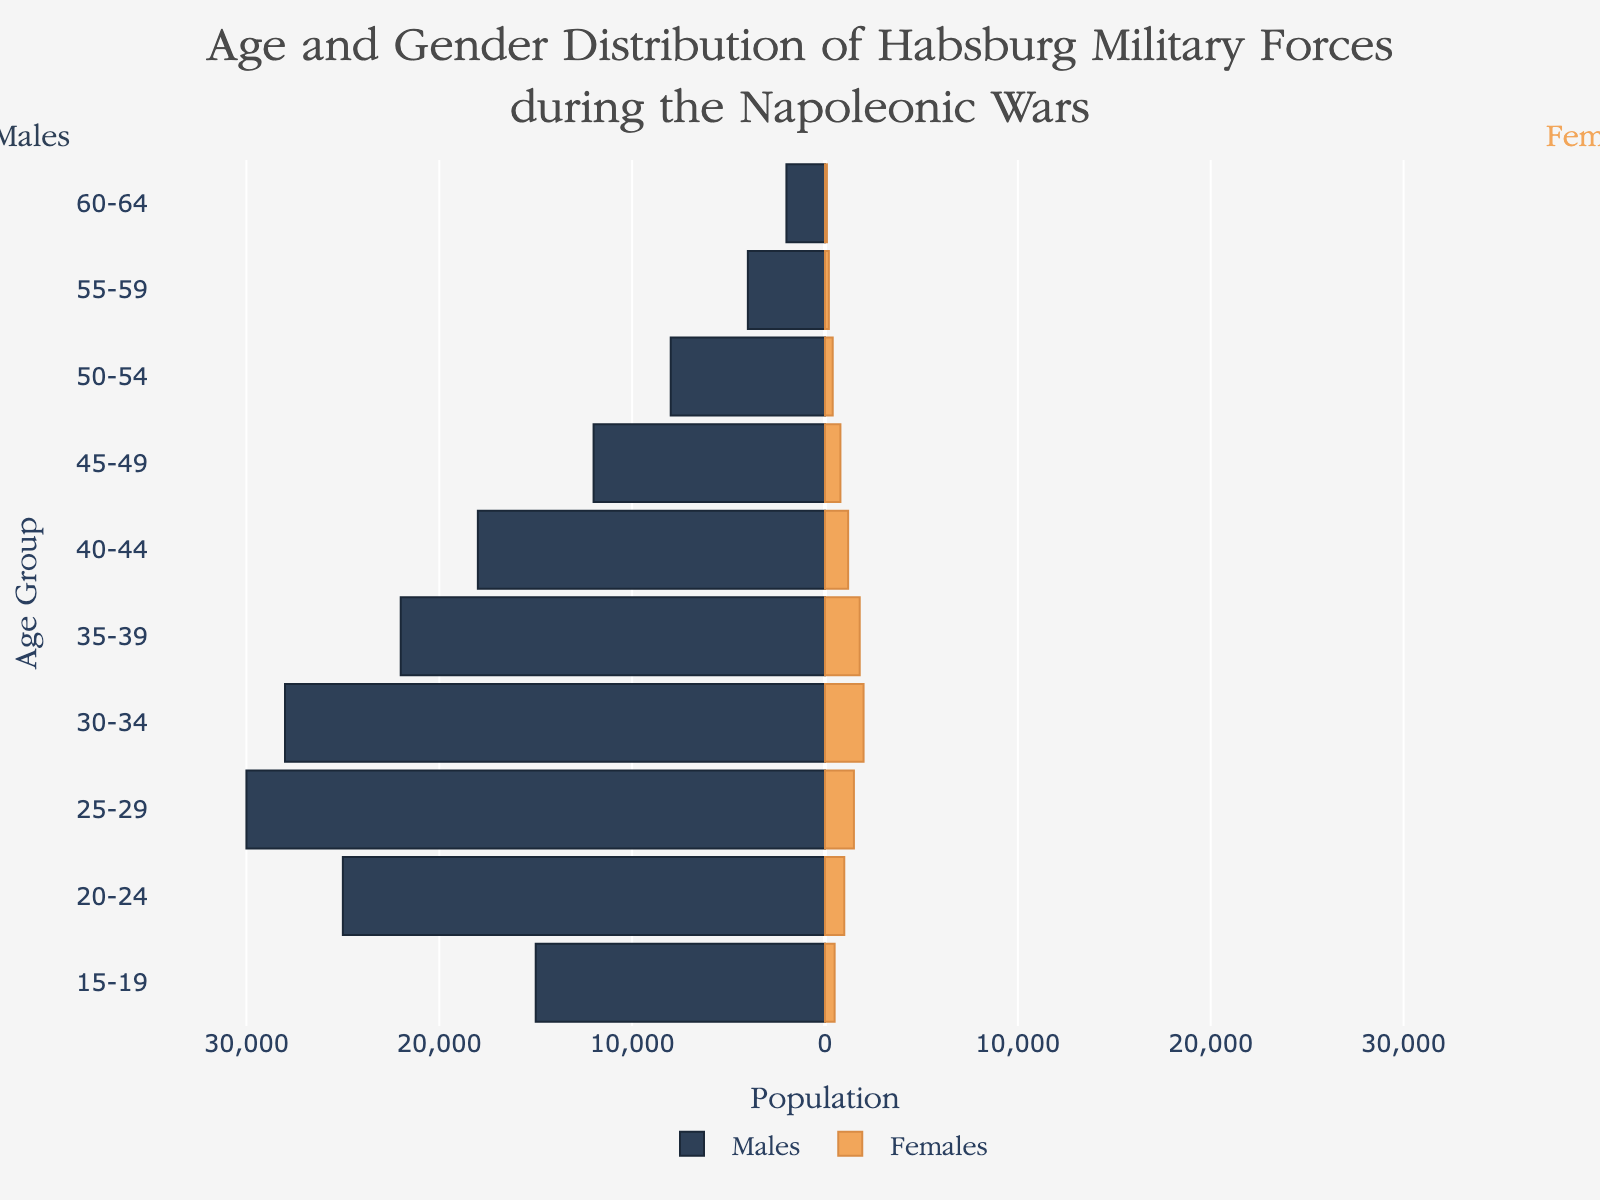What is the maximum number of males in the age groups? The age group with the highest number of males can be identified by looking at the longest bar on the left side of the pyramid. The 25-29 age group has the longest bar with 30,000 males.
Answer: 30,000 What is the age group with the highest number of females? The age group with the highest number of females is the one with the longest bar on the right side of the pyramid. The 30-34 age group has the longest bar with 2000 females.
Answer: 30-34 Compare the number of males and females in the 45-49 age group. On the left side of the pyramid, the 45-49 age group has a bar representing 12,000 males. On the right side, the same age group has a bar representing 800 females. Comparing these numbers, there are more males than females by 11,200 individuals.
Answer: Males are greater by 11,200 How many males are in the 35-39 and 40-44 age groups combined? Add the number of males in the 35-39 age group (22,000) to the number of males in the 40-44 age group (18,000). The combined total is 40,000.
Answer: 40,000 Which age group has the smallest number of females? The age group with the shortest bar on the right side of the pyramid is the one with the smallest number of females. The 60-64 age group has the shortest bar with 100 females.
Answer: 60-64 What is the total population of females across all age groups? Add the number of females in all age groups: 500 + 1000 + 1500 + 2000 + 1800 + 1200 + 800 + 400 + 200 + 100 = 9500.
Answer: 9500 Are there more males or females in the 20-24 age group? Comparing the bars for the 20-24 age group, the left side represents 25,000 males, and the right side represents 1,000 females. There are significantly more males than females.
Answer: Males What is the average number of males in the 15-19 and 20-24 age groups? Add the number of males in the 15-19 (15,000) and 20-24 (25,000) age groups, then divide by 2 to find the average: (15,000 + 25,000) / 2 = 20,000.
Answer: 20,000 Which age group shows the closest balance between the number of males and females? By comparing the lengths of the bars on both sides of the pyramid, the age group with the smallest difference between males and females is the 50-54 age group with 8,000 males and 400 females, showing a difference of 7,600.
Answer: 50-54 